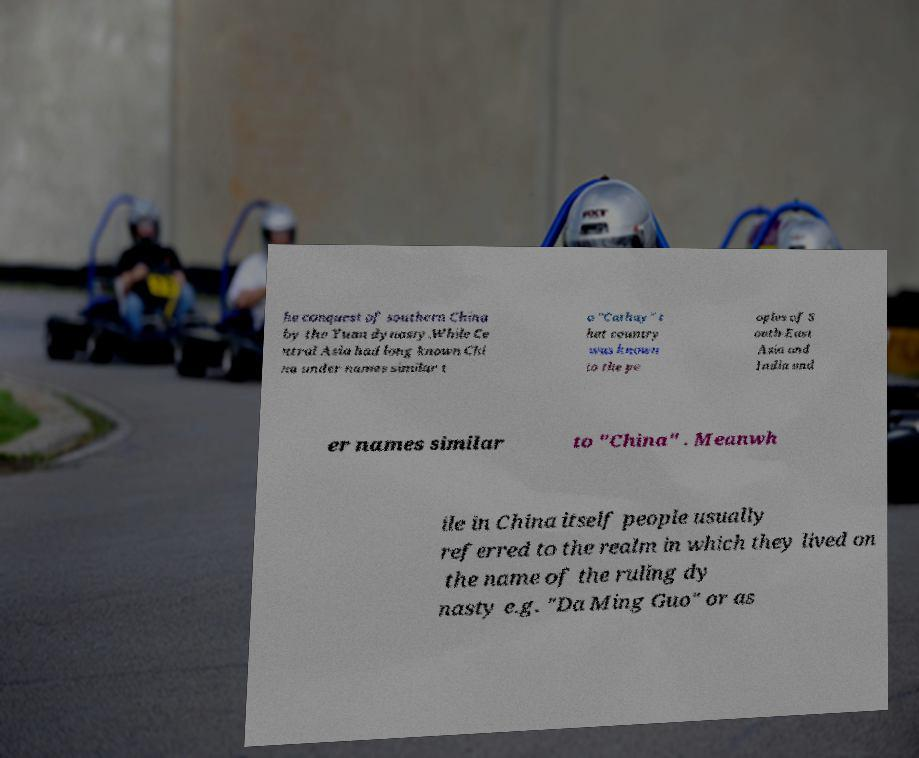For documentation purposes, I need the text within this image transcribed. Could you provide that? he conquest of southern China by the Yuan dynasty.While Ce ntral Asia had long known Chi na under names similar t o "Cathay" t hat country was known to the pe oples of S outh-East Asia and India und er names similar to "China" . Meanwh ile in China itself people usually referred to the realm in which they lived on the name of the ruling dy nasty e.g. "Da Ming Guo" or as 